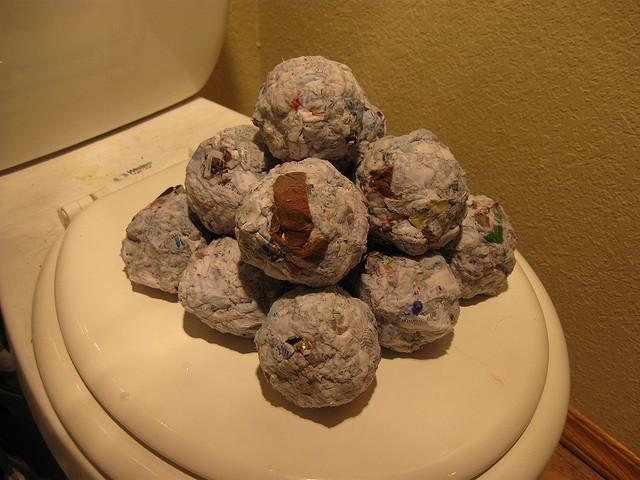Is that a band aid?
Be succinct. Yes. Where is this picture taken?
Quick response, please. Bathroom. What are these objects sitting on?
Be succinct. Toilet. 